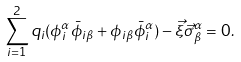<formula> <loc_0><loc_0><loc_500><loc_500>\sum _ { i = 1 } ^ { 2 } q _ { i } ( \phi _ { i } ^ { \alpha } { \bar { \phi } } _ { i \beta } + \phi _ { i \beta } { \bar { \phi } } _ { i } ^ { \alpha } ) - { \vec { \xi } } { \vec { \sigma } } ^ { \alpha } _ { \beta } = 0 .</formula> 